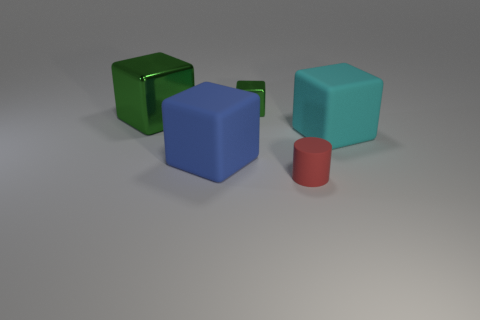There is a cyan block that is the same size as the blue cube; what material is it?
Your answer should be compact. Rubber. What material is the thing that is both right of the tiny block and left of the cyan object?
Provide a short and direct response. Rubber. Is there a cylinder?
Provide a short and direct response. Yes. There is a small matte object; is its color the same as the object on the left side of the blue rubber thing?
Your answer should be very brief. No. There is a large thing that is the same color as the tiny cube; what is it made of?
Your answer should be compact. Metal. Is there anything else that is the same shape as the small metal object?
Your response must be concise. Yes. What shape is the big object that is behind the large rubber block that is right of the rubber block left of the red cylinder?
Keep it short and to the point. Cube. The tiny green thing has what shape?
Your answer should be very brief. Cube. What is the color of the shiny object that is behind the large green cube?
Offer a very short reply. Green. Is the size of the rubber block in front of the cyan thing the same as the tiny red cylinder?
Make the answer very short. No. 